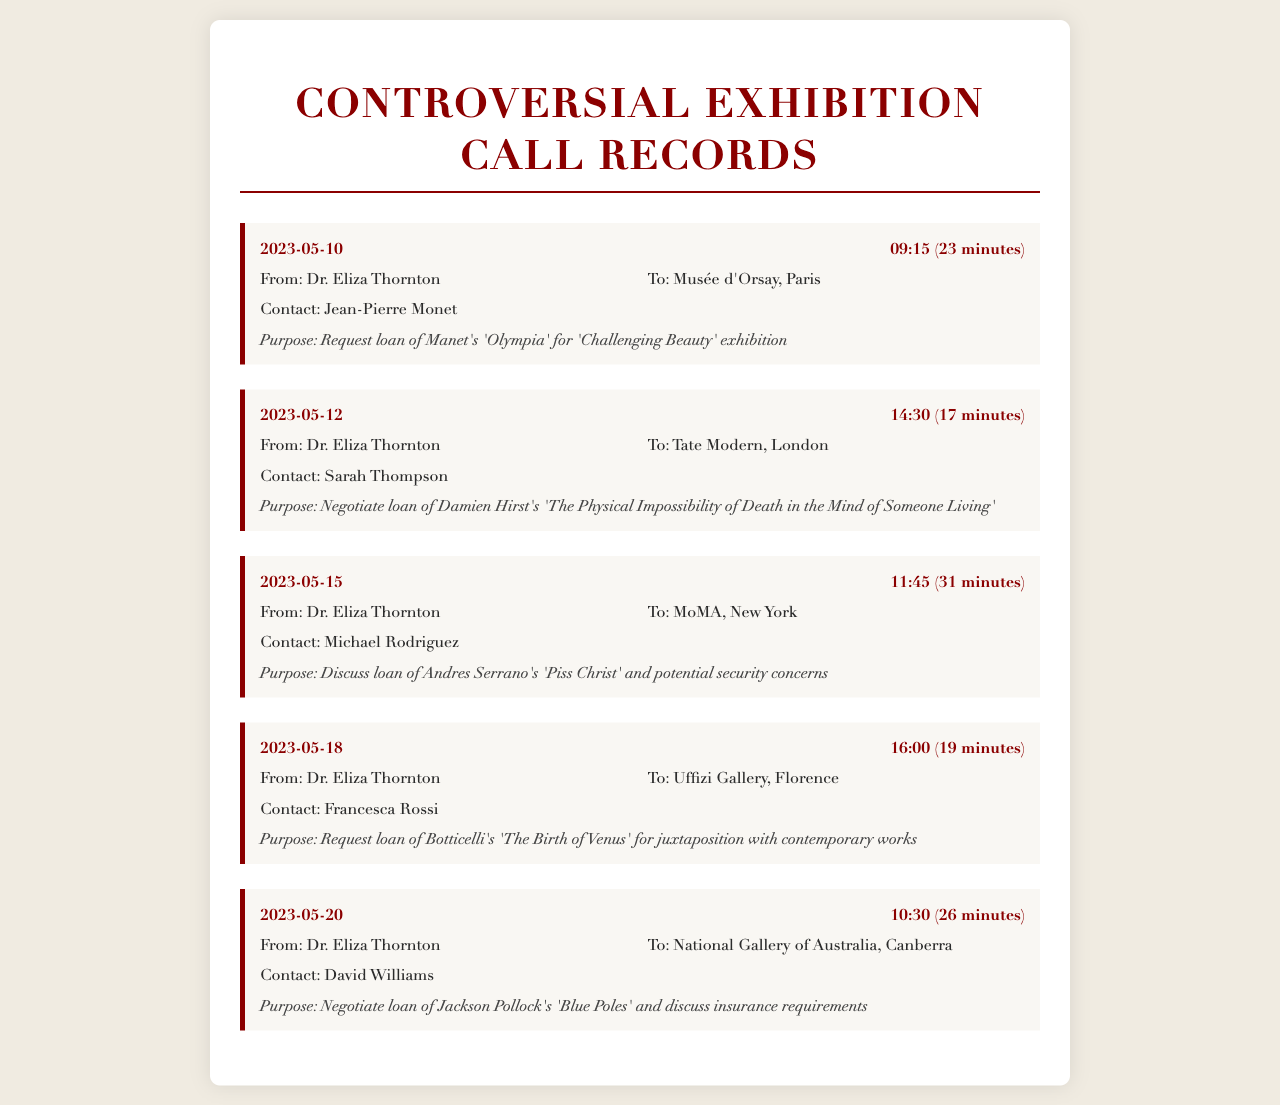What is the date of the call to Musée d'Orsay? The date of the call to Musée d'Orsay is found in the first call record, which indicates when the call occurred.
Answer: 2023-05-10 Who was the contact person for the call to Tate Modern? The contact person for the call to Tate Modern is mentioned in the details of the second call record.
Answer: Sarah Thompson What was the purpose of the call to Uffizi Gallery? The purpose of the call to Uffizi Gallery is stated in the fourth call record and explains the reason for the communication.
Answer: Request loan of Botticelli's 'The Birth of Venus' for juxtaposition with contemporary works How long was the call to MoMA? The duration of the call to MoMA is specified in the call header for that record, indicating the length of the conversation.
Answer: 31 minutes What artwork was discussed in the call to National Gallery of Australia? The specific artwork involved in the call to National Gallery of Australia is detailed in the call purpose found within that record.
Answer: Jackson Pollock's 'Blue Poles' What is the earliest date of the calls recorded? The earliest date is found by looking at the first entry in the call list to determine the date of the initial communication.
Answer: 2023-05-10 What gallery was contacted on May 20th? The gallery contacted on May 20th can be found in the date and recipient details of that specific call record.
Answer: National Gallery of Australia, Canberra How many calls are recorded in total? The total number of calls can be determined by counting the individual call record entries presented in the document.
Answer: 5 